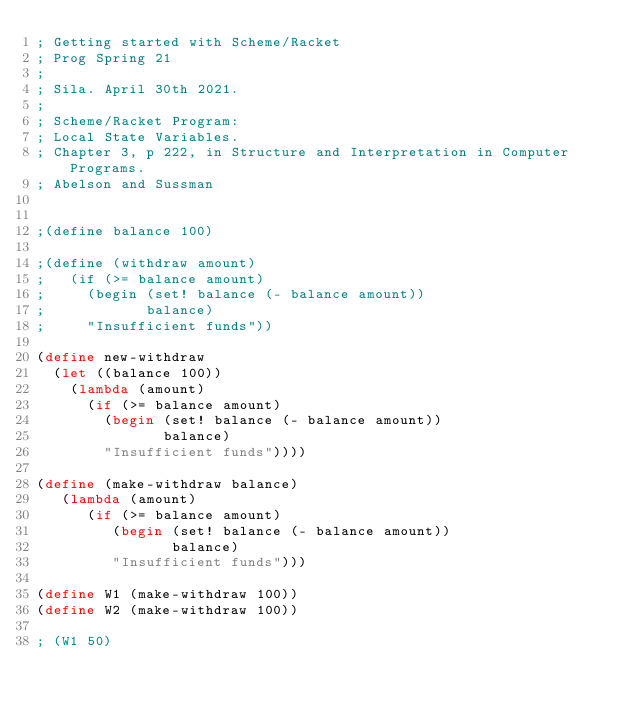Convert code to text. <code><loc_0><loc_0><loc_500><loc_500><_Scheme_>; Getting started with Scheme/Racket
; Prog Spring 21
; 
; Sila. April 30th 2021.
;
; Scheme/Racket Program:
; Local State Variables. 
; Chapter 3, p 222, in Structure and Interpretation in Computer Programs.
; Abelson and Sussman


;(define balance 100)

;(define (withdraw amount)
;   (if (>= balance amount)
;     (begin (set! balance (- balance amount))
;            balance)
;     "Insufficient funds"))

(define new-withdraw
  (let ((balance 100))
    (lambda (amount)
      (if (>= balance amount)
        (begin (set! balance (- balance amount))
               balance)
        "Insufficient funds"))))

(define (make-withdraw balance)
   (lambda (amount)
      (if (>= balance amount)
         (begin (set! balance (- balance amount))
                balance)
         "Insufficient funds")))

(define W1 (make-withdraw 100))
(define W2 (make-withdraw 100))

; (W1 50)</code> 